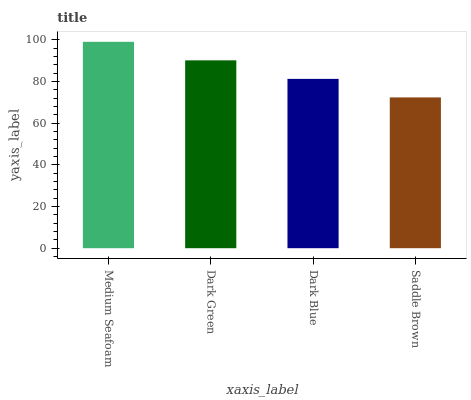Is Dark Green the minimum?
Answer yes or no. No. Is Dark Green the maximum?
Answer yes or no. No. Is Medium Seafoam greater than Dark Green?
Answer yes or no. Yes. Is Dark Green less than Medium Seafoam?
Answer yes or no. Yes. Is Dark Green greater than Medium Seafoam?
Answer yes or no. No. Is Medium Seafoam less than Dark Green?
Answer yes or no. No. Is Dark Green the high median?
Answer yes or no. Yes. Is Dark Blue the low median?
Answer yes or no. Yes. Is Saddle Brown the high median?
Answer yes or no. No. Is Dark Green the low median?
Answer yes or no. No. 